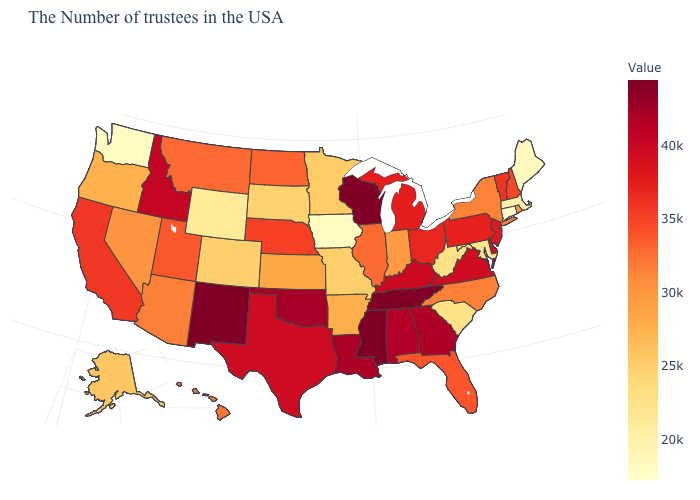Which states have the lowest value in the USA?
Concise answer only. Connecticut. Which states have the lowest value in the MidWest?
Short answer required. Iowa. Which states have the lowest value in the West?
Write a very short answer. Washington. Does New Mexico have the highest value in the West?
Give a very brief answer. Yes. Does North Dakota have a lower value than Arkansas?
Give a very brief answer. No. Does Maryland have the lowest value in the South?
Answer briefly. Yes. Does the map have missing data?
Concise answer only. No. Does Connecticut have the lowest value in the USA?
Quick response, please. Yes. 